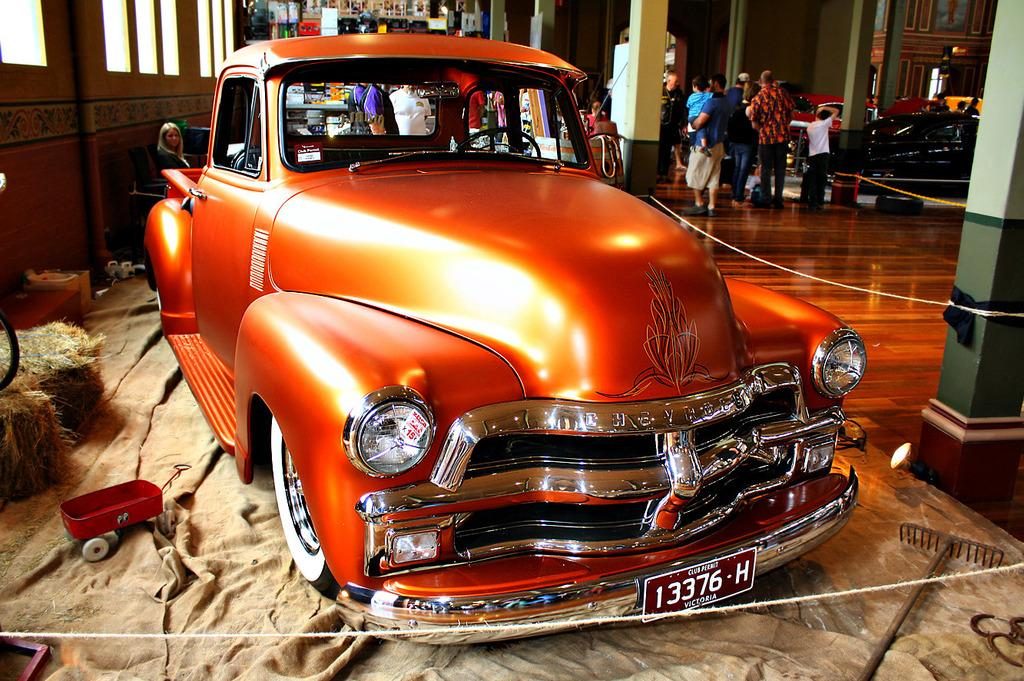What is the main subject in the image? There is a vehicle in the image. What can be seen beside the vehicle? There are objects placed on the floor beside the vehicle. What is visible in the background of the image? There are people standing in the background of the image and a wall is visible. How many chairs are visible in the image? There are no chairs visible in the image. What type of curtain is hanging from the wall in the image? There is no curtain present in the image; only a wall is visible in the background. 